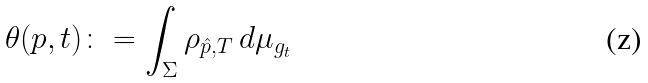<formula> <loc_0><loc_0><loc_500><loc_500>\theta ( p , t ) \colon = \int _ { \Sigma } \rho _ { \hat { p } , T } \, d \mu _ { g _ { t } }</formula> 